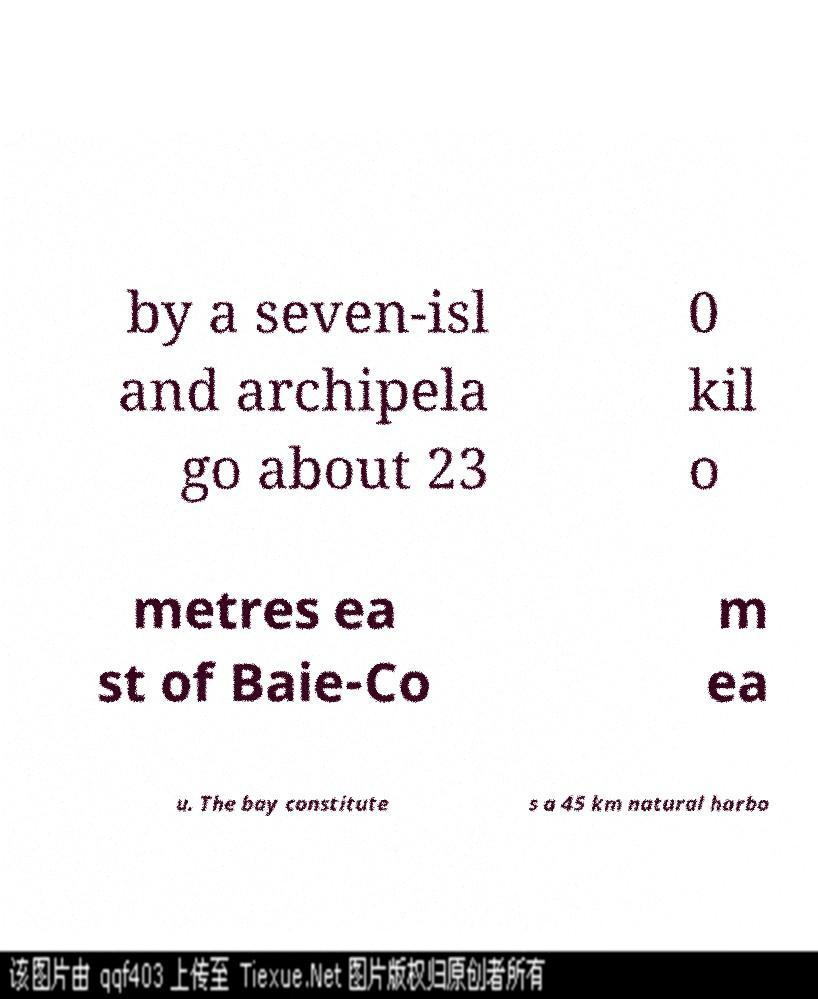I need the written content from this picture converted into text. Can you do that? by a seven-isl and archipela go about 23 0 kil o metres ea st of Baie-Co m ea u. The bay constitute s a 45 km natural harbo 